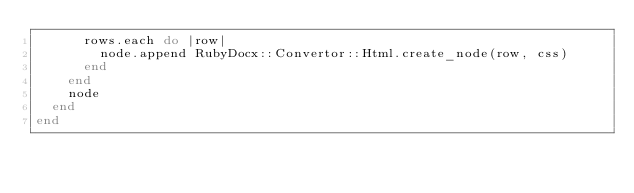Convert code to text. <code><loc_0><loc_0><loc_500><loc_500><_Ruby_>      rows.each do |row|
        node.append RubyDocx::Convertor::Html.create_node(row, css)
      end
    end
    node
  end
end</code> 